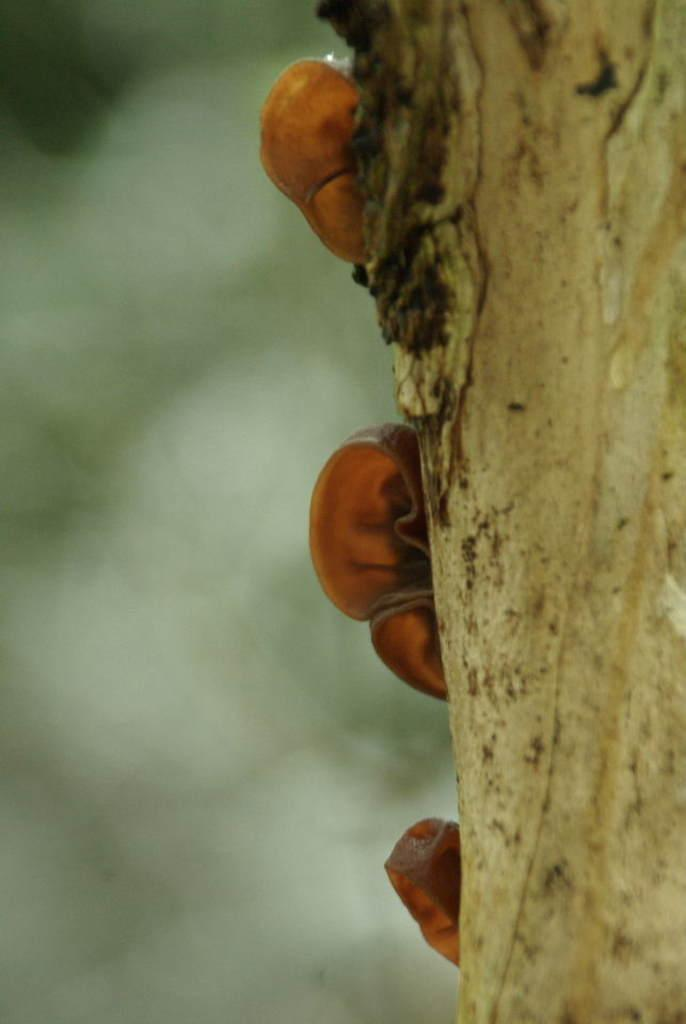What type of creatures can be seen in the image? There are insects in the image. Where are the insects located? The insects are on the bark of a tree. What type of drug is the insect holding in the image? There is no drug present in the image; it features insects on the bark of a tree. 